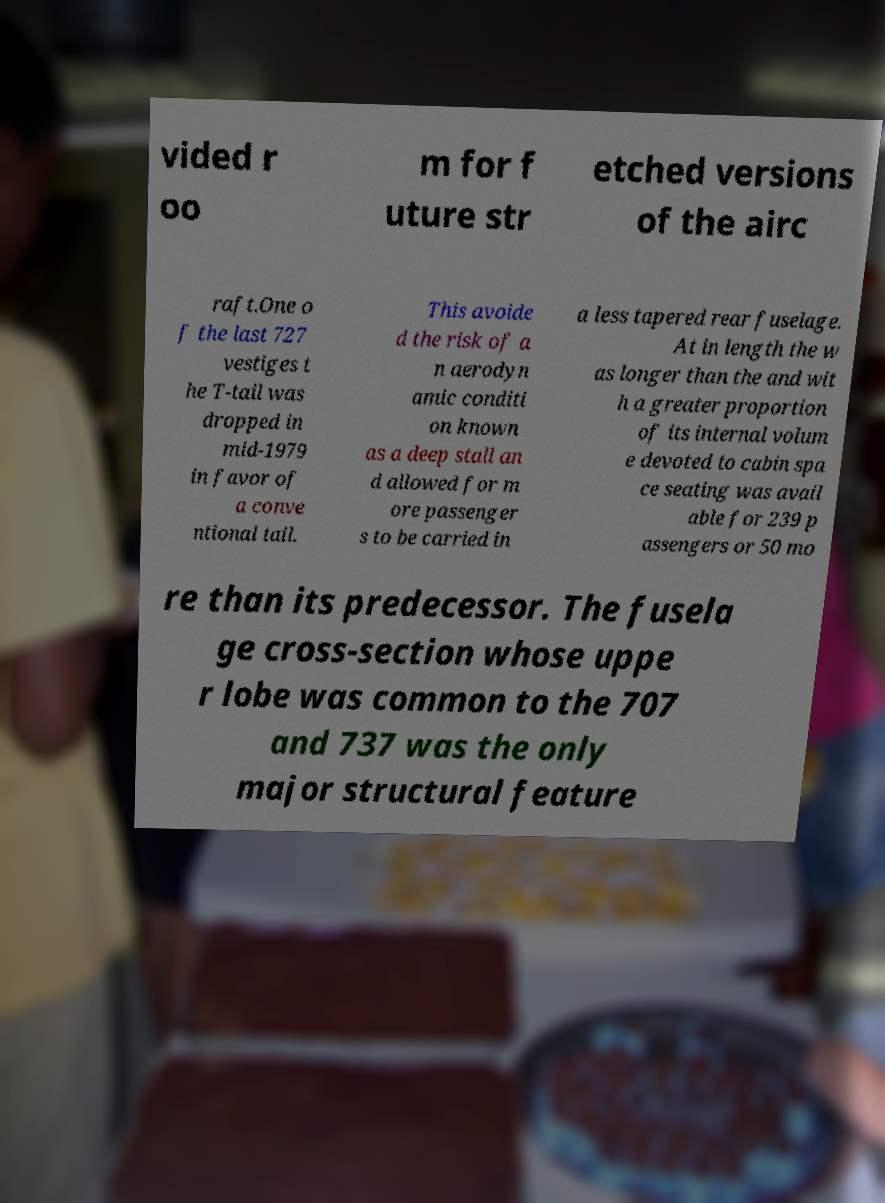Can you accurately transcribe the text from the provided image for me? vided r oo m for f uture str etched versions of the airc raft.One o f the last 727 vestiges t he T-tail was dropped in mid-1979 in favor of a conve ntional tail. This avoide d the risk of a n aerodyn amic conditi on known as a deep stall an d allowed for m ore passenger s to be carried in a less tapered rear fuselage. At in length the w as longer than the and wit h a greater proportion of its internal volum e devoted to cabin spa ce seating was avail able for 239 p assengers or 50 mo re than its predecessor. The fusela ge cross-section whose uppe r lobe was common to the 707 and 737 was the only major structural feature 